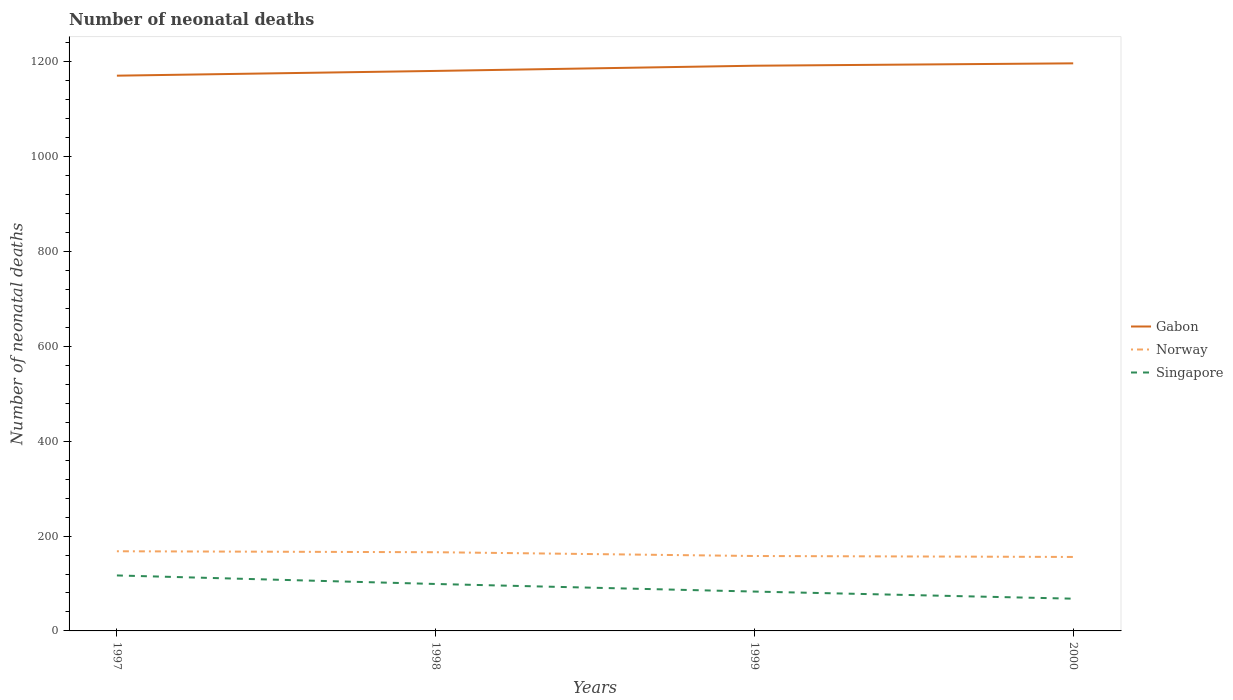Does the line corresponding to Gabon intersect with the line corresponding to Singapore?
Your answer should be compact. No. Across all years, what is the maximum number of neonatal deaths in in Singapore?
Ensure brevity in your answer.  68. In which year was the number of neonatal deaths in in Gabon maximum?
Keep it short and to the point. 1997. What is the total number of neonatal deaths in in Norway in the graph?
Provide a short and direct response. 10. What is the difference between the highest and the second highest number of neonatal deaths in in Norway?
Make the answer very short. 12. How many lines are there?
Keep it short and to the point. 3. What is the difference between two consecutive major ticks on the Y-axis?
Offer a very short reply. 200. Are the values on the major ticks of Y-axis written in scientific E-notation?
Provide a short and direct response. No. Does the graph contain any zero values?
Keep it short and to the point. No. How many legend labels are there?
Your answer should be very brief. 3. What is the title of the graph?
Keep it short and to the point. Number of neonatal deaths. What is the label or title of the Y-axis?
Your answer should be compact. Number of neonatal deaths. What is the Number of neonatal deaths of Gabon in 1997?
Your answer should be very brief. 1171. What is the Number of neonatal deaths of Norway in 1997?
Give a very brief answer. 168. What is the Number of neonatal deaths in Singapore in 1997?
Offer a terse response. 117. What is the Number of neonatal deaths of Gabon in 1998?
Your response must be concise. 1181. What is the Number of neonatal deaths in Norway in 1998?
Provide a succinct answer. 166. What is the Number of neonatal deaths of Gabon in 1999?
Your answer should be compact. 1192. What is the Number of neonatal deaths in Norway in 1999?
Keep it short and to the point. 158. What is the Number of neonatal deaths of Gabon in 2000?
Your response must be concise. 1197. What is the Number of neonatal deaths of Norway in 2000?
Your answer should be compact. 156. Across all years, what is the maximum Number of neonatal deaths of Gabon?
Provide a short and direct response. 1197. Across all years, what is the maximum Number of neonatal deaths in Norway?
Offer a very short reply. 168. Across all years, what is the maximum Number of neonatal deaths of Singapore?
Make the answer very short. 117. Across all years, what is the minimum Number of neonatal deaths of Gabon?
Offer a very short reply. 1171. Across all years, what is the minimum Number of neonatal deaths in Norway?
Your answer should be compact. 156. Across all years, what is the minimum Number of neonatal deaths of Singapore?
Provide a succinct answer. 68. What is the total Number of neonatal deaths of Gabon in the graph?
Ensure brevity in your answer.  4741. What is the total Number of neonatal deaths of Norway in the graph?
Your response must be concise. 648. What is the total Number of neonatal deaths of Singapore in the graph?
Your answer should be very brief. 367. What is the difference between the Number of neonatal deaths of Norway in 1997 and that in 1998?
Provide a succinct answer. 2. What is the difference between the Number of neonatal deaths of Gabon in 1997 and that in 2000?
Keep it short and to the point. -26. What is the difference between the Number of neonatal deaths in Gabon in 1998 and that in 1999?
Offer a terse response. -11. What is the difference between the Number of neonatal deaths in Norway in 1998 and that in 2000?
Your answer should be very brief. 10. What is the difference between the Number of neonatal deaths of Gabon in 1999 and that in 2000?
Offer a terse response. -5. What is the difference between the Number of neonatal deaths in Norway in 1999 and that in 2000?
Ensure brevity in your answer.  2. What is the difference between the Number of neonatal deaths of Singapore in 1999 and that in 2000?
Ensure brevity in your answer.  15. What is the difference between the Number of neonatal deaths of Gabon in 1997 and the Number of neonatal deaths of Norway in 1998?
Your answer should be compact. 1005. What is the difference between the Number of neonatal deaths of Gabon in 1997 and the Number of neonatal deaths of Singapore in 1998?
Give a very brief answer. 1072. What is the difference between the Number of neonatal deaths of Gabon in 1997 and the Number of neonatal deaths of Norway in 1999?
Your answer should be very brief. 1013. What is the difference between the Number of neonatal deaths of Gabon in 1997 and the Number of neonatal deaths of Singapore in 1999?
Your response must be concise. 1088. What is the difference between the Number of neonatal deaths in Gabon in 1997 and the Number of neonatal deaths in Norway in 2000?
Your answer should be very brief. 1015. What is the difference between the Number of neonatal deaths in Gabon in 1997 and the Number of neonatal deaths in Singapore in 2000?
Provide a succinct answer. 1103. What is the difference between the Number of neonatal deaths of Norway in 1997 and the Number of neonatal deaths of Singapore in 2000?
Your answer should be compact. 100. What is the difference between the Number of neonatal deaths in Gabon in 1998 and the Number of neonatal deaths in Norway in 1999?
Offer a very short reply. 1023. What is the difference between the Number of neonatal deaths of Gabon in 1998 and the Number of neonatal deaths of Singapore in 1999?
Give a very brief answer. 1098. What is the difference between the Number of neonatal deaths of Norway in 1998 and the Number of neonatal deaths of Singapore in 1999?
Your answer should be very brief. 83. What is the difference between the Number of neonatal deaths of Gabon in 1998 and the Number of neonatal deaths of Norway in 2000?
Keep it short and to the point. 1025. What is the difference between the Number of neonatal deaths of Gabon in 1998 and the Number of neonatal deaths of Singapore in 2000?
Give a very brief answer. 1113. What is the difference between the Number of neonatal deaths in Gabon in 1999 and the Number of neonatal deaths in Norway in 2000?
Your response must be concise. 1036. What is the difference between the Number of neonatal deaths of Gabon in 1999 and the Number of neonatal deaths of Singapore in 2000?
Offer a terse response. 1124. What is the difference between the Number of neonatal deaths in Norway in 1999 and the Number of neonatal deaths in Singapore in 2000?
Offer a terse response. 90. What is the average Number of neonatal deaths of Gabon per year?
Your answer should be very brief. 1185.25. What is the average Number of neonatal deaths of Norway per year?
Your answer should be compact. 162. What is the average Number of neonatal deaths in Singapore per year?
Make the answer very short. 91.75. In the year 1997, what is the difference between the Number of neonatal deaths of Gabon and Number of neonatal deaths of Norway?
Offer a very short reply. 1003. In the year 1997, what is the difference between the Number of neonatal deaths in Gabon and Number of neonatal deaths in Singapore?
Give a very brief answer. 1054. In the year 1998, what is the difference between the Number of neonatal deaths in Gabon and Number of neonatal deaths in Norway?
Your answer should be very brief. 1015. In the year 1998, what is the difference between the Number of neonatal deaths in Gabon and Number of neonatal deaths in Singapore?
Offer a terse response. 1082. In the year 1999, what is the difference between the Number of neonatal deaths of Gabon and Number of neonatal deaths of Norway?
Give a very brief answer. 1034. In the year 1999, what is the difference between the Number of neonatal deaths of Gabon and Number of neonatal deaths of Singapore?
Ensure brevity in your answer.  1109. In the year 1999, what is the difference between the Number of neonatal deaths in Norway and Number of neonatal deaths in Singapore?
Keep it short and to the point. 75. In the year 2000, what is the difference between the Number of neonatal deaths in Gabon and Number of neonatal deaths in Norway?
Your answer should be very brief. 1041. In the year 2000, what is the difference between the Number of neonatal deaths of Gabon and Number of neonatal deaths of Singapore?
Offer a very short reply. 1129. In the year 2000, what is the difference between the Number of neonatal deaths in Norway and Number of neonatal deaths in Singapore?
Offer a very short reply. 88. What is the ratio of the Number of neonatal deaths in Norway in 1997 to that in 1998?
Your answer should be very brief. 1.01. What is the ratio of the Number of neonatal deaths of Singapore in 1997 to that in 1998?
Ensure brevity in your answer.  1.18. What is the ratio of the Number of neonatal deaths of Gabon in 1997 to that in 1999?
Provide a succinct answer. 0.98. What is the ratio of the Number of neonatal deaths of Norway in 1997 to that in 1999?
Give a very brief answer. 1.06. What is the ratio of the Number of neonatal deaths in Singapore in 1997 to that in 1999?
Give a very brief answer. 1.41. What is the ratio of the Number of neonatal deaths of Gabon in 1997 to that in 2000?
Keep it short and to the point. 0.98. What is the ratio of the Number of neonatal deaths in Singapore in 1997 to that in 2000?
Keep it short and to the point. 1.72. What is the ratio of the Number of neonatal deaths of Gabon in 1998 to that in 1999?
Ensure brevity in your answer.  0.99. What is the ratio of the Number of neonatal deaths in Norway in 1998 to that in 1999?
Your response must be concise. 1.05. What is the ratio of the Number of neonatal deaths of Singapore in 1998 to that in 1999?
Ensure brevity in your answer.  1.19. What is the ratio of the Number of neonatal deaths in Gabon in 1998 to that in 2000?
Your response must be concise. 0.99. What is the ratio of the Number of neonatal deaths in Norway in 1998 to that in 2000?
Your answer should be compact. 1.06. What is the ratio of the Number of neonatal deaths of Singapore in 1998 to that in 2000?
Your response must be concise. 1.46. What is the ratio of the Number of neonatal deaths of Gabon in 1999 to that in 2000?
Your answer should be very brief. 1. What is the ratio of the Number of neonatal deaths in Norway in 1999 to that in 2000?
Keep it short and to the point. 1.01. What is the ratio of the Number of neonatal deaths in Singapore in 1999 to that in 2000?
Your answer should be very brief. 1.22. What is the difference between the highest and the second highest Number of neonatal deaths of Gabon?
Provide a succinct answer. 5. What is the difference between the highest and the second highest Number of neonatal deaths of Norway?
Give a very brief answer. 2. What is the difference between the highest and the second highest Number of neonatal deaths of Singapore?
Your response must be concise. 18. 